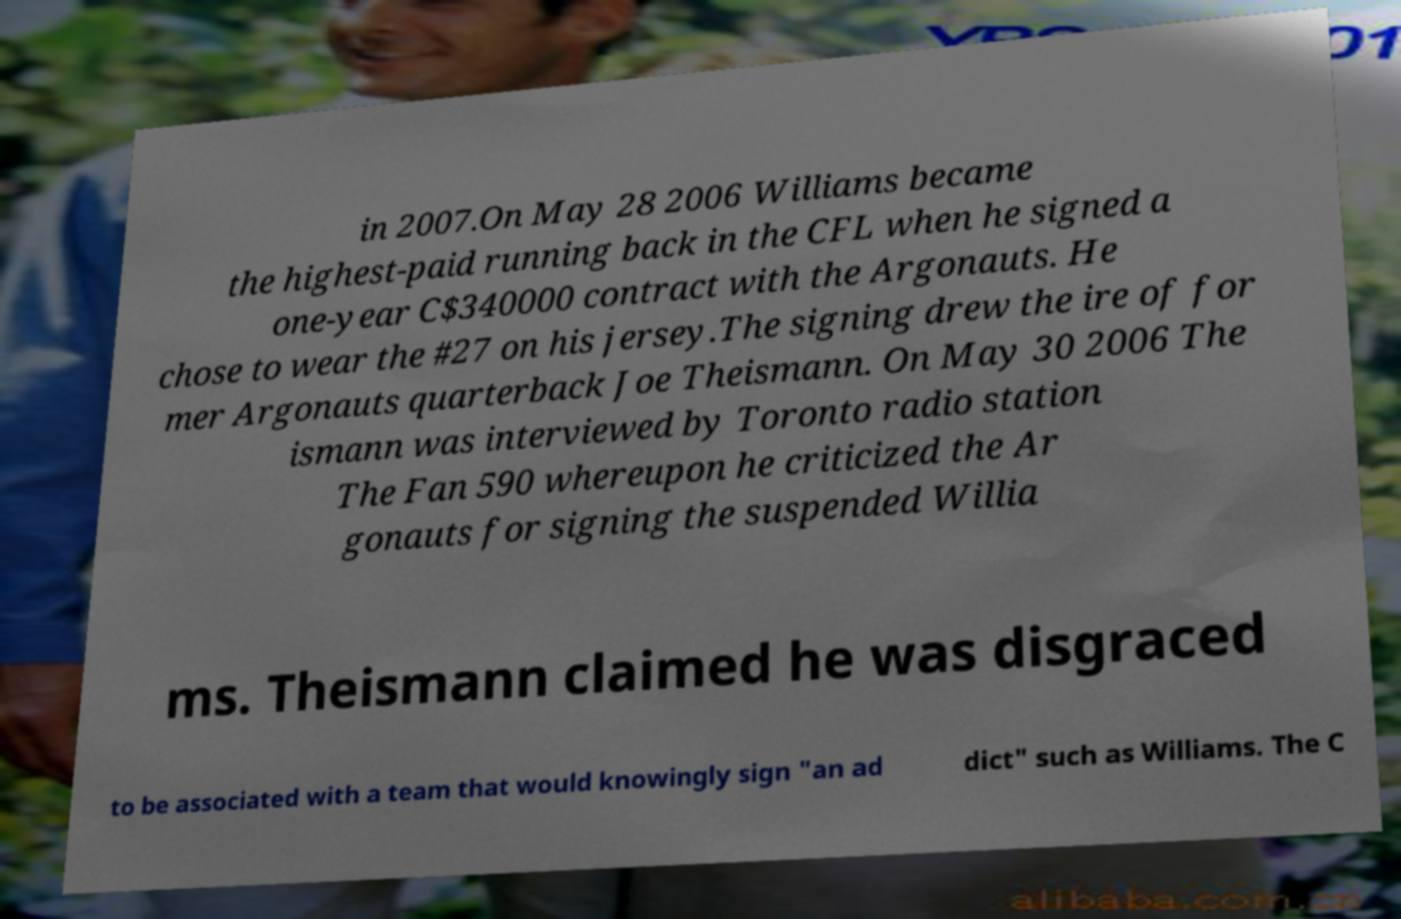Please identify and transcribe the text found in this image. in 2007.On May 28 2006 Williams became the highest-paid running back in the CFL when he signed a one-year C$340000 contract with the Argonauts. He chose to wear the #27 on his jersey.The signing drew the ire of for mer Argonauts quarterback Joe Theismann. On May 30 2006 The ismann was interviewed by Toronto radio station The Fan 590 whereupon he criticized the Ar gonauts for signing the suspended Willia ms. Theismann claimed he was disgraced to be associated with a team that would knowingly sign "an ad dict" such as Williams. The C 